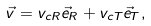Convert formula to latex. <formula><loc_0><loc_0><loc_500><loc_500>\vec { v } = v _ { c R } \vec { e } _ { R } + v _ { c T } \vec { e } _ { T } ,</formula> 